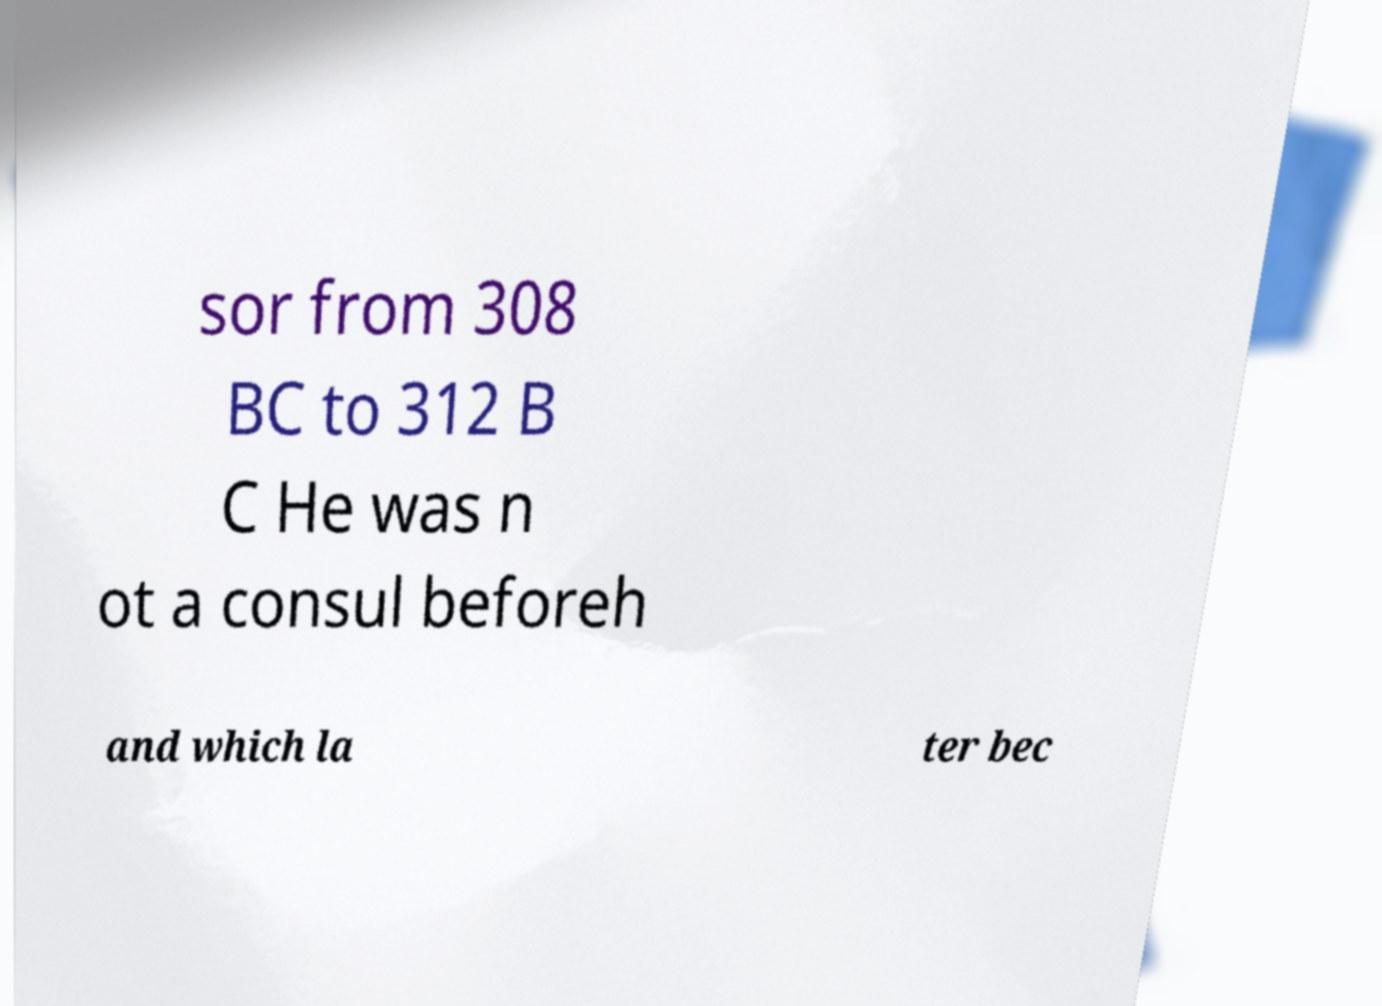There's text embedded in this image that I need extracted. Can you transcribe it verbatim? sor from 308 BC to 312 B C He was n ot a consul beforeh and which la ter bec 